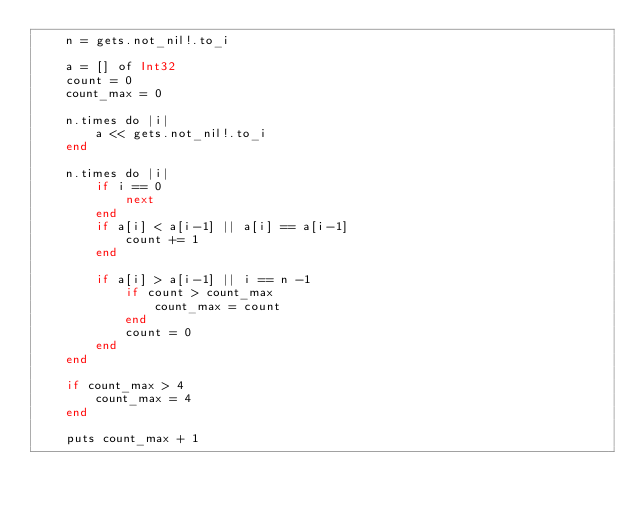Convert code to text. <code><loc_0><loc_0><loc_500><loc_500><_Crystal_>    n = gets.not_nil!.to_i
     
    a = [] of Int32
    count = 0
    count_max = 0
     
    n.times do |i|
        a << gets.not_nil!.to_i
    end
     
    n.times do |i|
        if i == 0
            next
        end
        if a[i] < a[i-1] || a[i] == a[i-1]
            count += 1
        end
     
        if a[i] > a[i-1] || i == n -1 
            if count > count_max
                count_max = count
            end
            count = 0
        end
    end
     
    if count_max > 4
        count_max = 4
    end

    puts count_max + 1</code> 